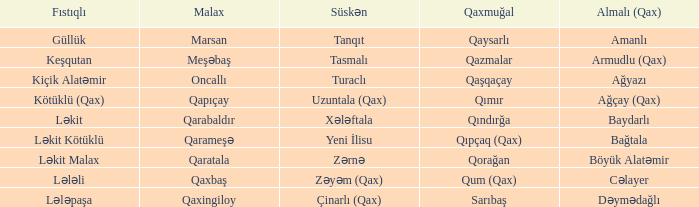What is the Süskən village with a Malax village meşəbaş? Tasmalı. 